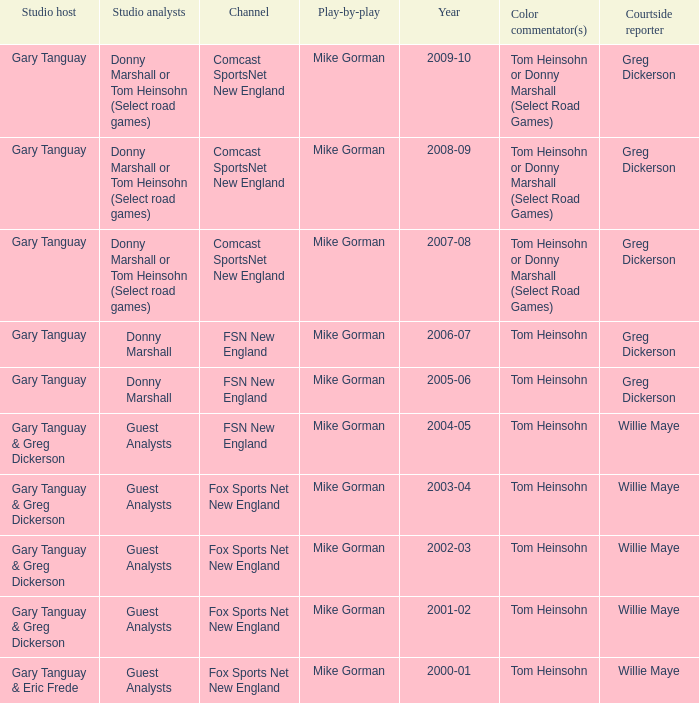Which Courtside reporter has a Channel of fsn new england in 2006-07? Greg Dickerson. 